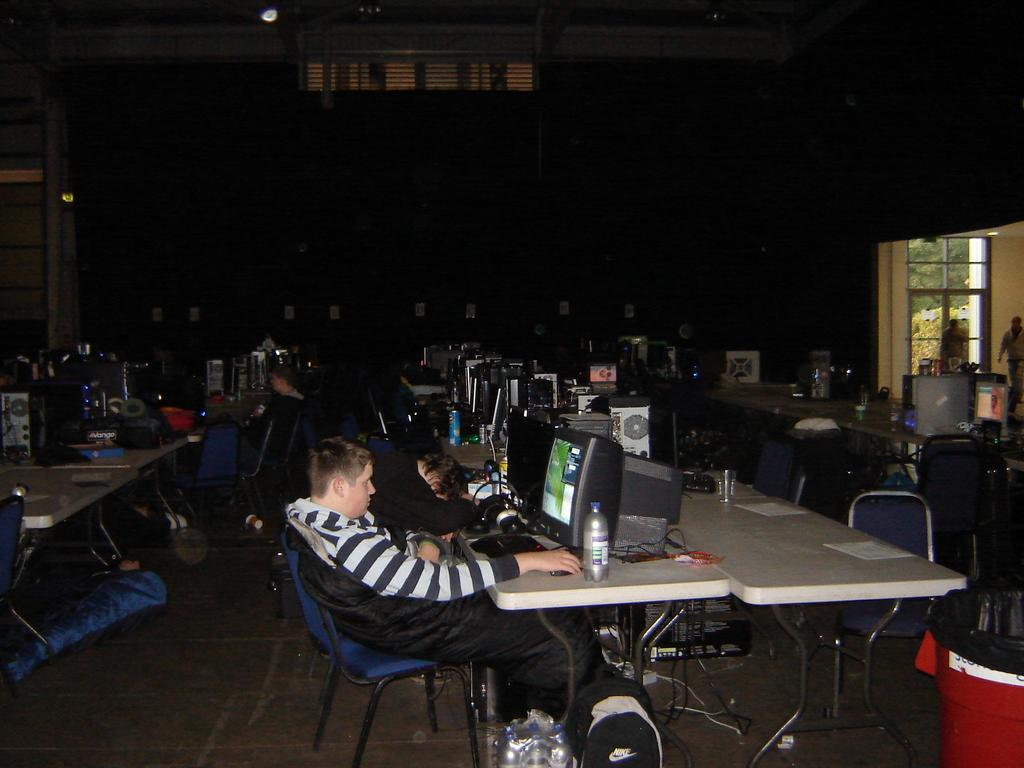What is the man in the image doing? The man is sitting on a chair in the image. What can be seen on the desk top in the image? There is no information about the desk top in the provided facts. What is on the table in the image? There is a bottle and a paper on a table in the image. How many chairs are visible in the image? There is one chair the man is sitting on, and there are other chairs visible in the background of the image. What is the background of the image like? In the background of the image, there is another table, a wall, and a window. What type of seed is growing on the wall in the image? There is no seed or plant growing on the wall in the image; it only shows a man sitting on a chair, a table with a bottle and paper, and a background with another table, a wall, and a window. 